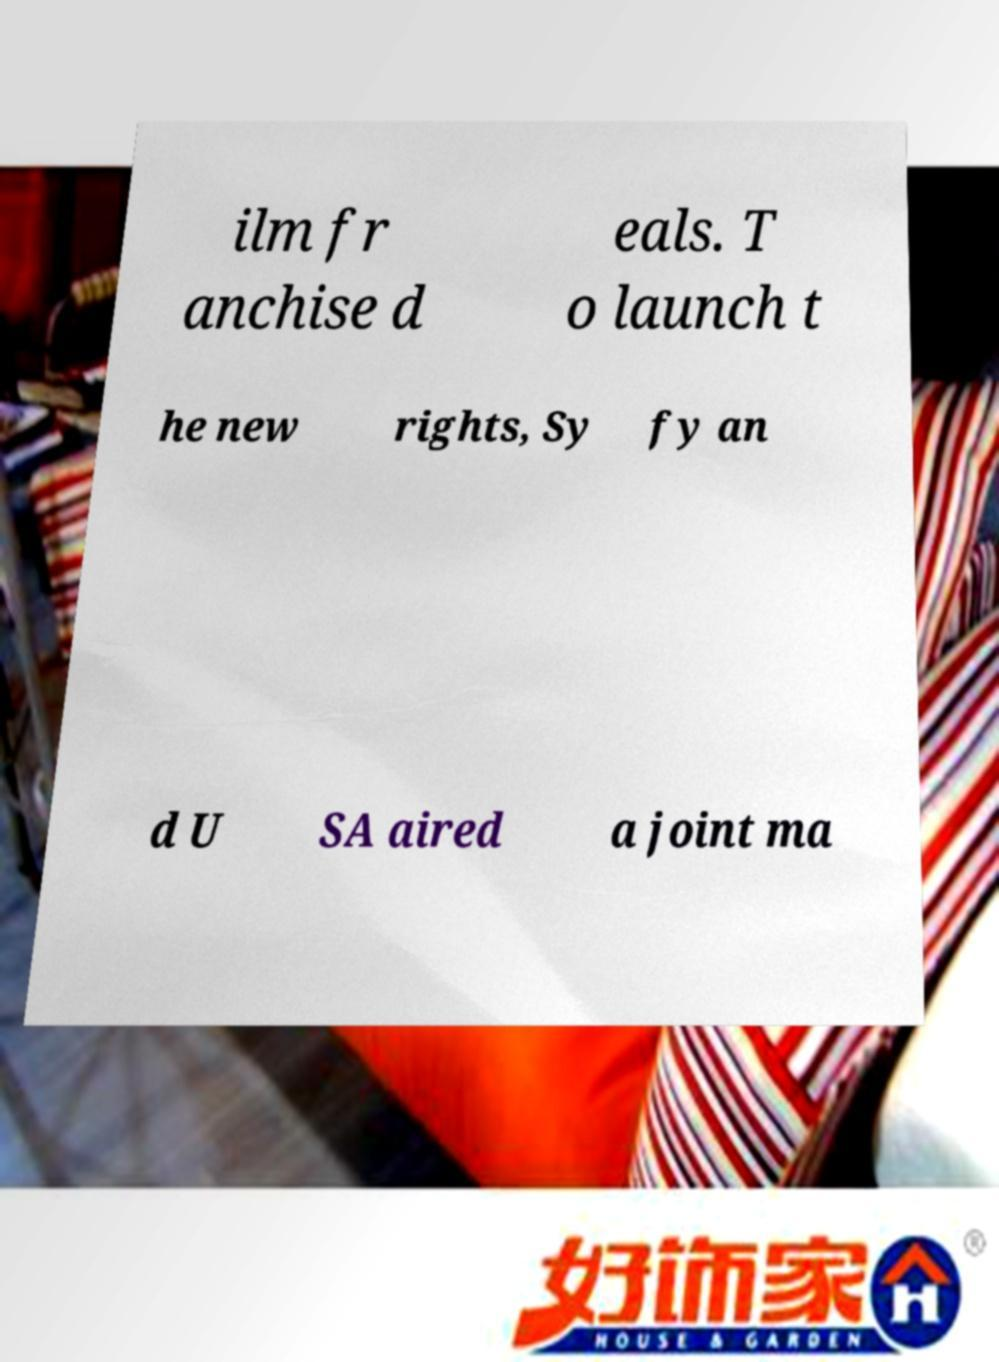For documentation purposes, I need the text within this image transcribed. Could you provide that? ilm fr anchise d eals. T o launch t he new rights, Sy fy an d U SA aired a joint ma 